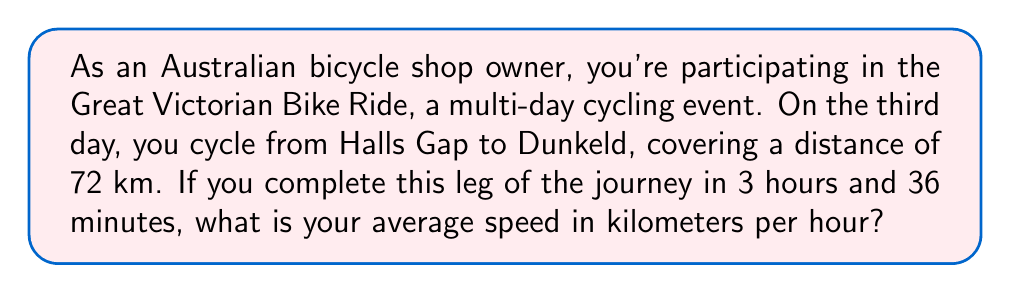Could you help me with this problem? To calculate the average speed, we need to use the formula:

$$ \text{Average Speed} = \frac{\text{Distance}}{\text{Time}} $$

Let's break down the problem and solve it step by step:

1. Distance given: 72 km

2. Time given: 3 hours and 36 minutes
   We need to convert this to hours:
   $3 \text{ hours} + \frac{36}{60} \text{ hours} = 3.6 \text{ hours}$

3. Now we can plug these values into our formula:

   $$ \text{Average Speed} = \frac{72 \text{ km}}{3.6 \text{ hours}} $$

4. Perform the division:

   $$ \text{Average Speed} = 20 \text{ km/h} $$

Therefore, your average speed during this leg of the Great Victorian Bike Ride is 20 kilometers per hour.
Answer: $20 \text{ km/h}$ 